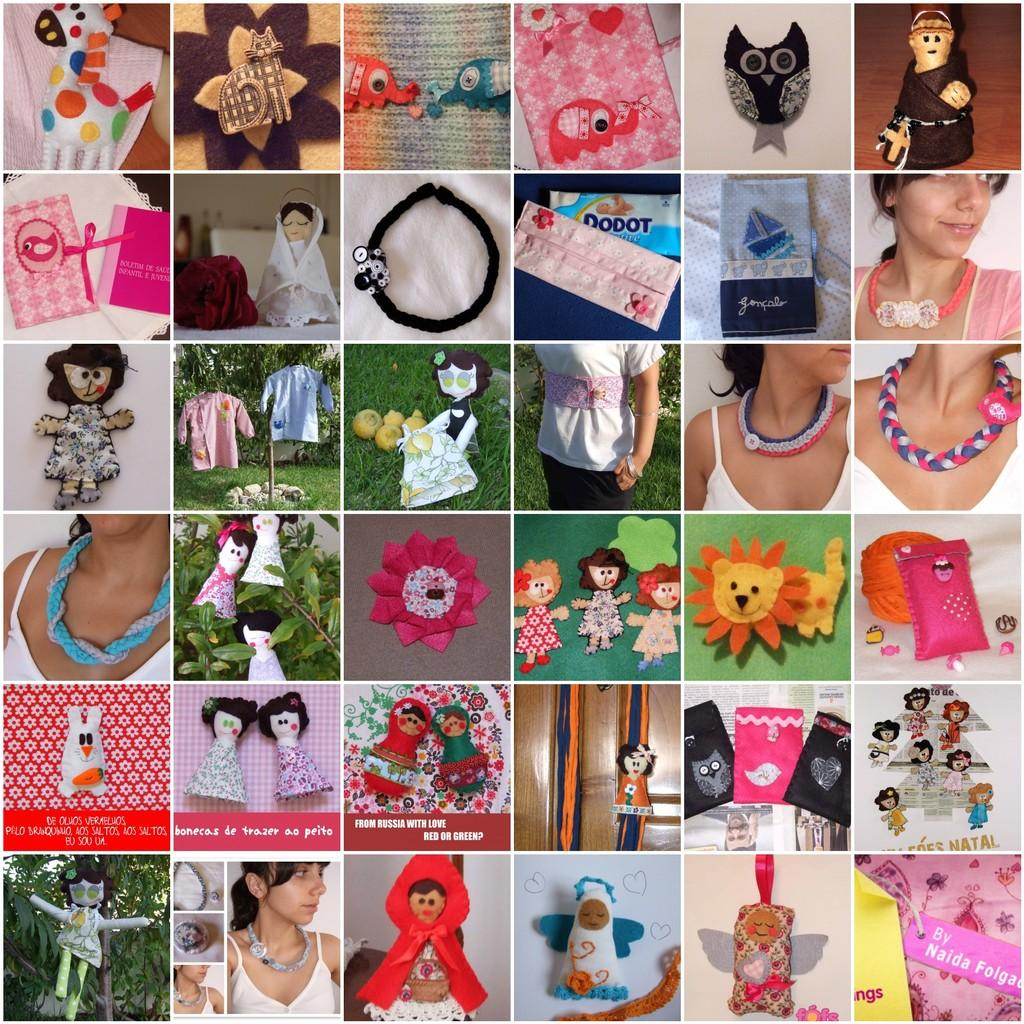What type of artwork is featured in the image? The image contains a collage of various pictures. What subjects are depicted in the collage? There are pictures of a group of people, dolls, plants, and clothes in the collage. Can you describe the content of the collage in more detail? The collage consists of a group of pictures featuring people, dolls, plants, and clothes. What type of slope can be seen in the image? There is no slope present in the image; it features a collage of various pictures. What type of can is visible in the image? There is no can present in the image; it features a collage of various pictures. 